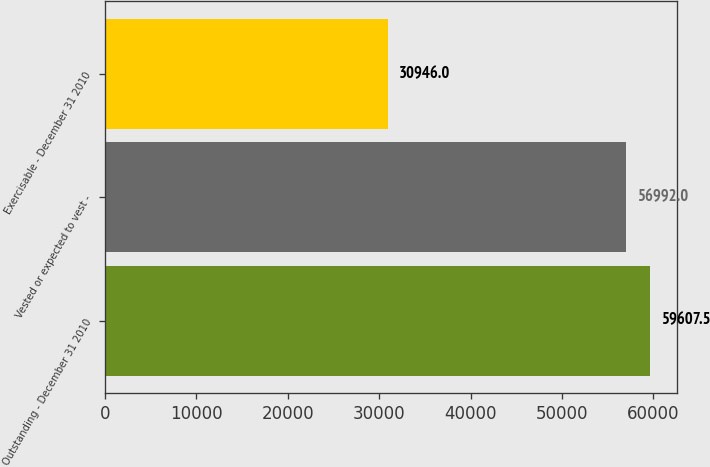<chart> <loc_0><loc_0><loc_500><loc_500><bar_chart><fcel>Outstanding - December 31 2010<fcel>Vested or expected to vest -<fcel>Exercisable - December 31 2010<nl><fcel>59607.5<fcel>56992<fcel>30946<nl></chart> 